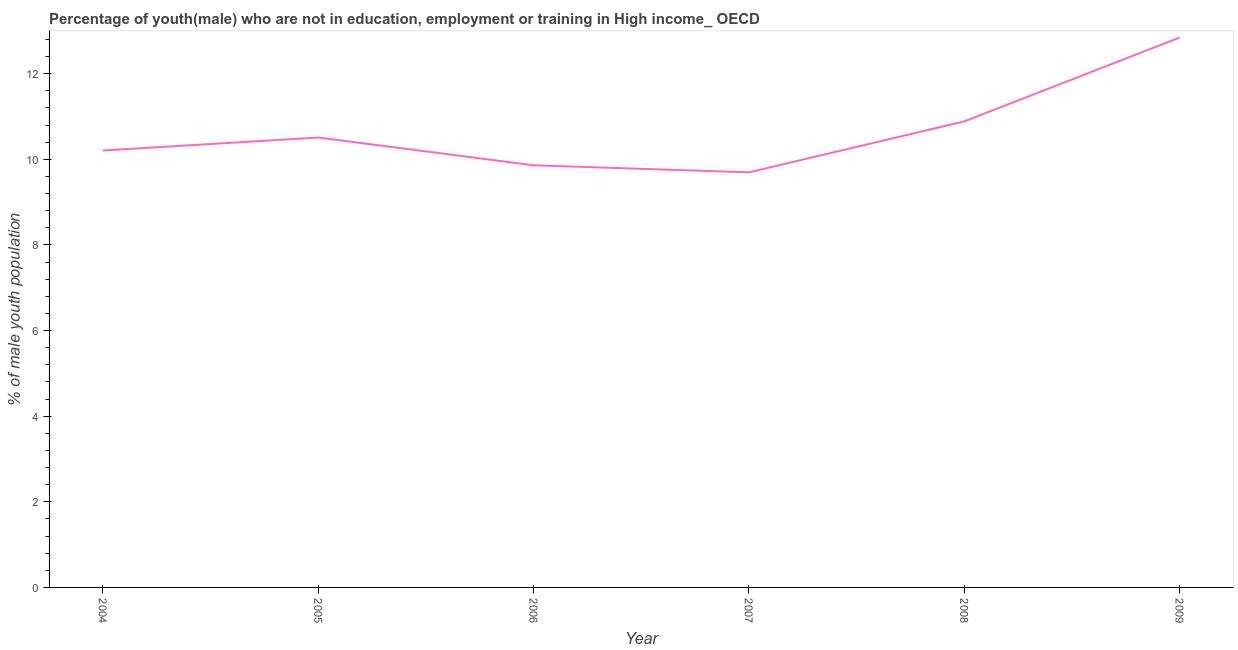What is the unemployed male youth population in 2005?
Your response must be concise. 10.51. Across all years, what is the maximum unemployed male youth population?
Ensure brevity in your answer.  12.84. Across all years, what is the minimum unemployed male youth population?
Offer a terse response. 9.7. In which year was the unemployed male youth population maximum?
Ensure brevity in your answer.  2009. What is the sum of the unemployed male youth population?
Provide a short and direct response. 64. What is the difference between the unemployed male youth population in 2006 and 2007?
Ensure brevity in your answer.  0.16. What is the average unemployed male youth population per year?
Give a very brief answer. 10.67. What is the median unemployed male youth population?
Make the answer very short. 10.36. What is the ratio of the unemployed male youth population in 2005 to that in 2006?
Your answer should be compact. 1.07. Is the difference between the unemployed male youth population in 2004 and 2007 greater than the difference between any two years?
Make the answer very short. No. What is the difference between the highest and the second highest unemployed male youth population?
Provide a short and direct response. 1.96. Is the sum of the unemployed male youth population in 2004 and 2008 greater than the maximum unemployed male youth population across all years?
Provide a short and direct response. Yes. What is the difference between the highest and the lowest unemployed male youth population?
Make the answer very short. 3.15. In how many years, is the unemployed male youth population greater than the average unemployed male youth population taken over all years?
Provide a short and direct response. 2. How many lines are there?
Offer a very short reply. 1. How many years are there in the graph?
Offer a terse response. 6. Are the values on the major ticks of Y-axis written in scientific E-notation?
Your answer should be compact. No. Does the graph contain grids?
Your answer should be very brief. No. What is the title of the graph?
Your response must be concise. Percentage of youth(male) who are not in education, employment or training in High income_ OECD. What is the label or title of the X-axis?
Keep it short and to the point. Year. What is the label or title of the Y-axis?
Provide a succinct answer. % of male youth population. What is the % of male youth population of 2004?
Keep it short and to the point. 10.21. What is the % of male youth population of 2005?
Offer a very short reply. 10.51. What is the % of male youth population in 2006?
Your response must be concise. 9.86. What is the % of male youth population of 2007?
Keep it short and to the point. 9.7. What is the % of male youth population of 2008?
Your response must be concise. 10.89. What is the % of male youth population of 2009?
Offer a terse response. 12.84. What is the difference between the % of male youth population in 2004 and 2005?
Make the answer very short. -0.3. What is the difference between the % of male youth population in 2004 and 2006?
Keep it short and to the point. 0.35. What is the difference between the % of male youth population in 2004 and 2007?
Keep it short and to the point. 0.51. What is the difference between the % of male youth population in 2004 and 2008?
Provide a succinct answer. -0.68. What is the difference between the % of male youth population in 2004 and 2009?
Give a very brief answer. -2.64. What is the difference between the % of male youth population in 2005 and 2006?
Provide a succinct answer. 0.65. What is the difference between the % of male youth population in 2005 and 2007?
Provide a short and direct response. 0.81. What is the difference between the % of male youth population in 2005 and 2008?
Provide a succinct answer. -0.38. What is the difference between the % of male youth population in 2005 and 2009?
Provide a short and direct response. -2.33. What is the difference between the % of male youth population in 2006 and 2007?
Ensure brevity in your answer.  0.16. What is the difference between the % of male youth population in 2006 and 2008?
Keep it short and to the point. -1.03. What is the difference between the % of male youth population in 2006 and 2009?
Offer a very short reply. -2.98. What is the difference between the % of male youth population in 2007 and 2008?
Provide a succinct answer. -1.19. What is the difference between the % of male youth population in 2007 and 2009?
Ensure brevity in your answer.  -3.15. What is the difference between the % of male youth population in 2008 and 2009?
Your answer should be very brief. -1.96. What is the ratio of the % of male youth population in 2004 to that in 2005?
Keep it short and to the point. 0.97. What is the ratio of the % of male youth population in 2004 to that in 2006?
Provide a succinct answer. 1.03. What is the ratio of the % of male youth population in 2004 to that in 2007?
Offer a very short reply. 1.05. What is the ratio of the % of male youth population in 2004 to that in 2008?
Provide a short and direct response. 0.94. What is the ratio of the % of male youth population in 2004 to that in 2009?
Offer a very short reply. 0.8. What is the ratio of the % of male youth population in 2005 to that in 2006?
Provide a short and direct response. 1.07. What is the ratio of the % of male youth population in 2005 to that in 2007?
Offer a very short reply. 1.08. What is the ratio of the % of male youth population in 2005 to that in 2009?
Ensure brevity in your answer.  0.82. What is the ratio of the % of male youth population in 2006 to that in 2007?
Offer a terse response. 1.02. What is the ratio of the % of male youth population in 2006 to that in 2008?
Your answer should be compact. 0.91. What is the ratio of the % of male youth population in 2006 to that in 2009?
Make the answer very short. 0.77. What is the ratio of the % of male youth population in 2007 to that in 2008?
Your response must be concise. 0.89. What is the ratio of the % of male youth population in 2007 to that in 2009?
Ensure brevity in your answer.  0.76. What is the ratio of the % of male youth population in 2008 to that in 2009?
Your answer should be compact. 0.85. 